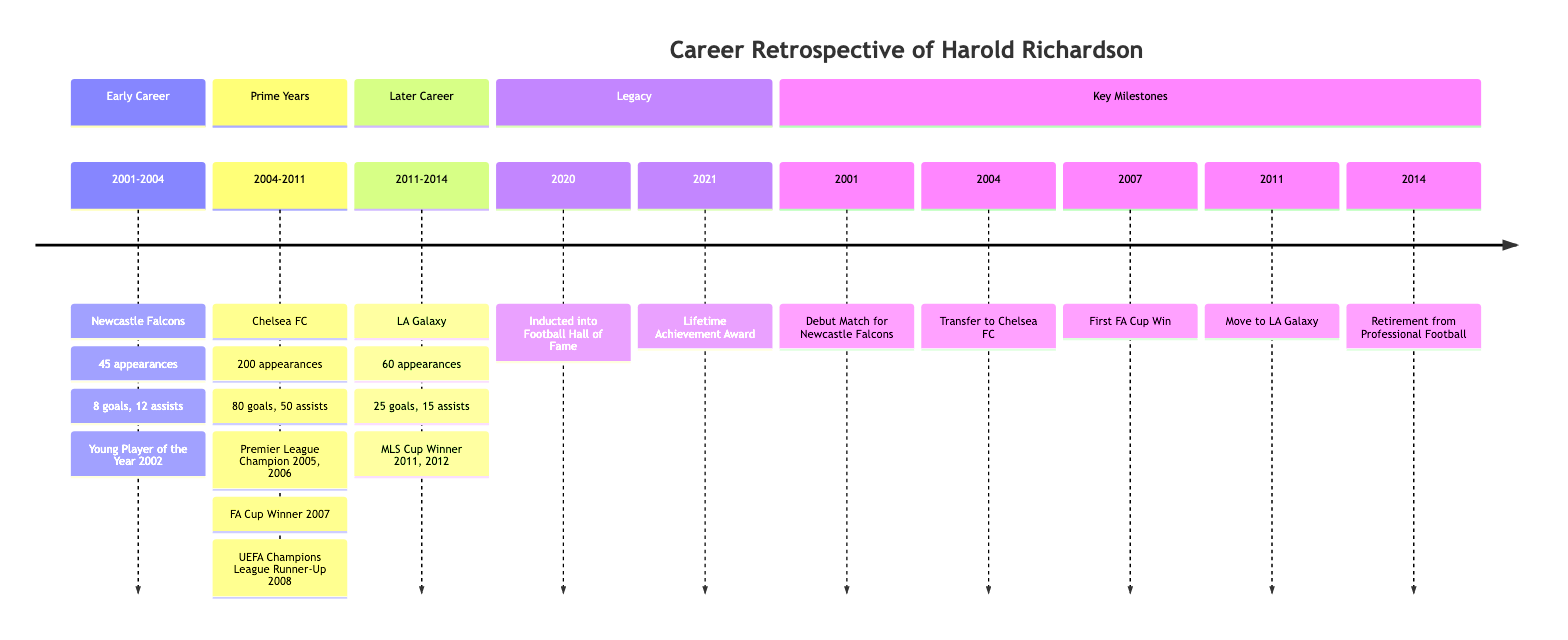What was Harold Richardson's debut match year? The diagram states that Harold Richardson played his debut match for Newcastle Falcons in 2001.
Answer: 2001 How many appearances did Harold Richardson make during his time at Chelsea FC? The section titled "Prime Years" indicates that he made 200 appearances while playing for Chelsea FC.
Answer: 200 What was Harold Richardson's first major trophy won? According to the "Key Milestones" section, Harold Richardson's first major trophy was the FA Cup in 2007.
Answer: FA Cup In which year did Harold Richardson retire from professional football? The diagram shows that Harold Richardson retired from professional football in 2014.
Answer: 2014 How many goals did Harold Richardson score while at LA Galaxy? In the "Later Career" section, it is noted that he scored 25 goals during his time at LA Galaxy.
Answer: 25 Which team did Harold Richardson play for immediately before LA Galaxy? The diagram records that he transferred from Chelsea FC to LA Galaxy in 2011, indicating Chelsea FC was his previous team.
Answer: Chelsea FC What are the total career goals scored by Harold Richardson based on the data provided? To find the total, we add the goals scored in each phase: 8 (Newcastle Falcons) + 80 (Chelsea FC) + 25 (LA Galaxy) which totals 113 goals.
Answer: 113 How many assists did Harold Richardson achieve in his entire career? By adding the assists from each team: 12 (Newcastle Falcons) + 50 (Chelsea FC) + 15 (LA Galaxy) results in 77 assists total in his career.
Answer: 77 In which year did Harold Richardson win the Lifetime Achievement Award? The diagram shows that he received the Lifetime Achievement Award in 2021.
Answer: 2021 